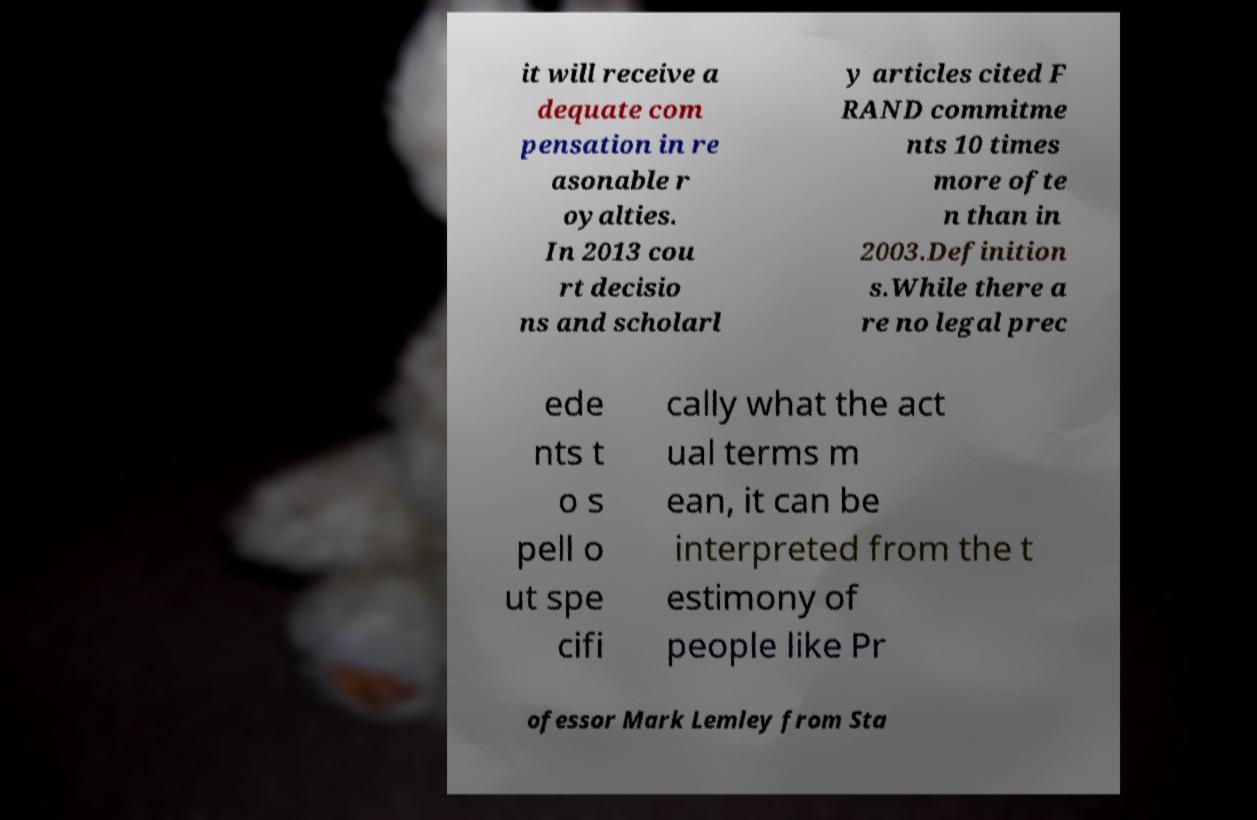I need the written content from this picture converted into text. Can you do that? it will receive a dequate com pensation in re asonable r oyalties. In 2013 cou rt decisio ns and scholarl y articles cited F RAND commitme nts 10 times more ofte n than in 2003.Definition s.While there a re no legal prec ede nts t o s pell o ut spe cifi cally what the act ual terms m ean, it can be interpreted from the t estimony of people like Pr ofessor Mark Lemley from Sta 